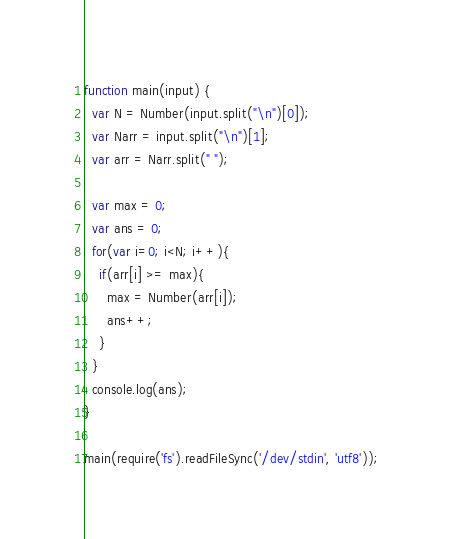Convert code to text. <code><loc_0><loc_0><loc_500><loc_500><_JavaScript_>function main(input) {
  var N = Number(input.split("\n")[0]);
  var Narr = input.split("\n")[1];
  var arr = Narr.split(" ");

  var max = 0;
  var ans = 0;
  for(var i=0; i<N; i++){
    if(arr[i] >= max){
      max = Number(arr[i]);
      ans++;
    }
  }
  console.log(ans);
}

main(require('fs').readFileSync('/dev/stdin', 'utf8'));
</code> 